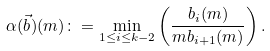<formula> <loc_0><loc_0><loc_500><loc_500>\alpha ( \vec { b } ) ( m ) \colon = \min _ { 1 \leq i \leq k - 2 } \left ( \frac { b _ { i } ( m ) } { m b _ { i + 1 } ( m ) } \right ) .</formula> 